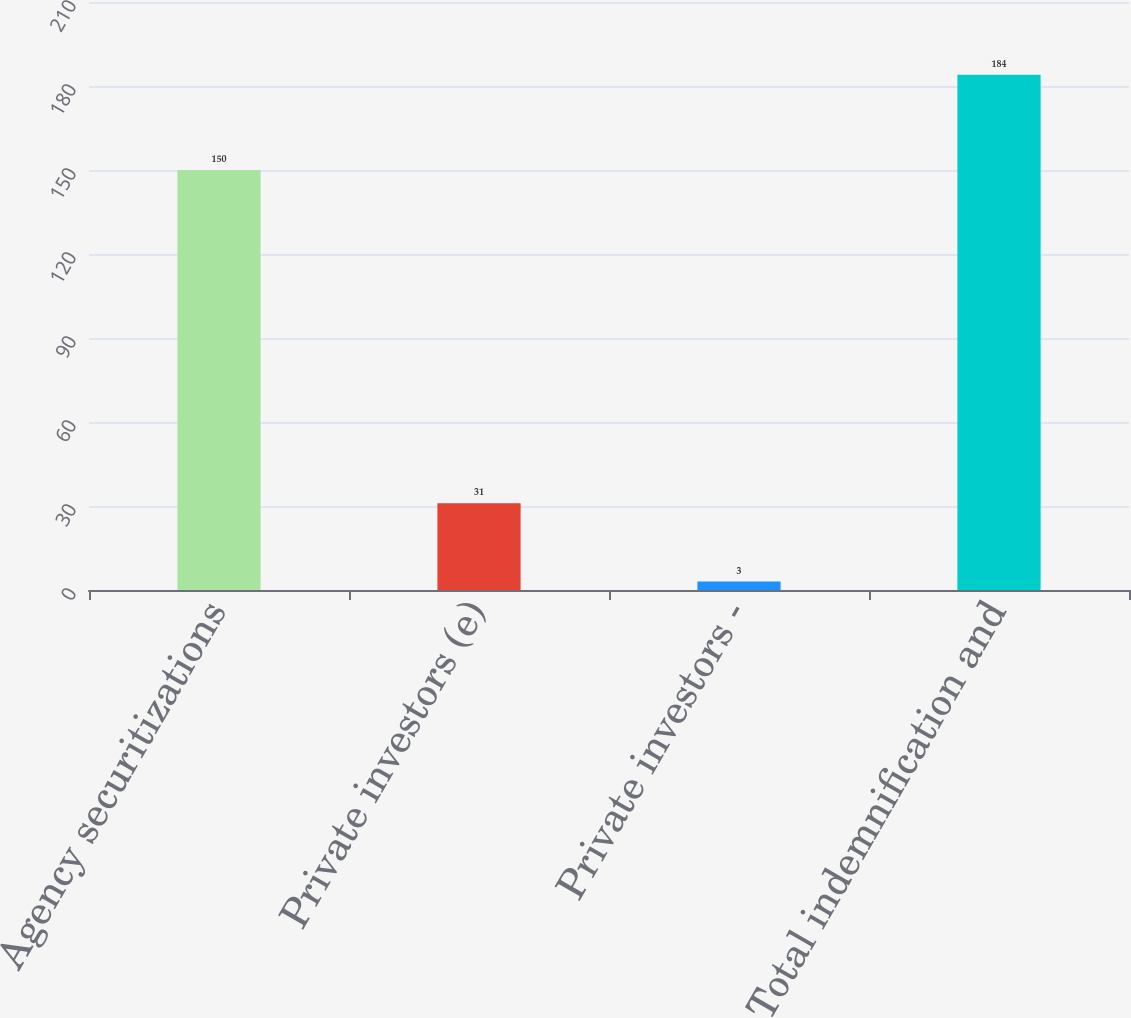Convert chart to OTSL. <chart><loc_0><loc_0><loc_500><loc_500><bar_chart><fcel>Agency securitizations<fcel>Private investors (e)<fcel>Private investors -<fcel>Total indemnification and<nl><fcel>150<fcel>31<fcel>3<fcel>184<nl></chart> 